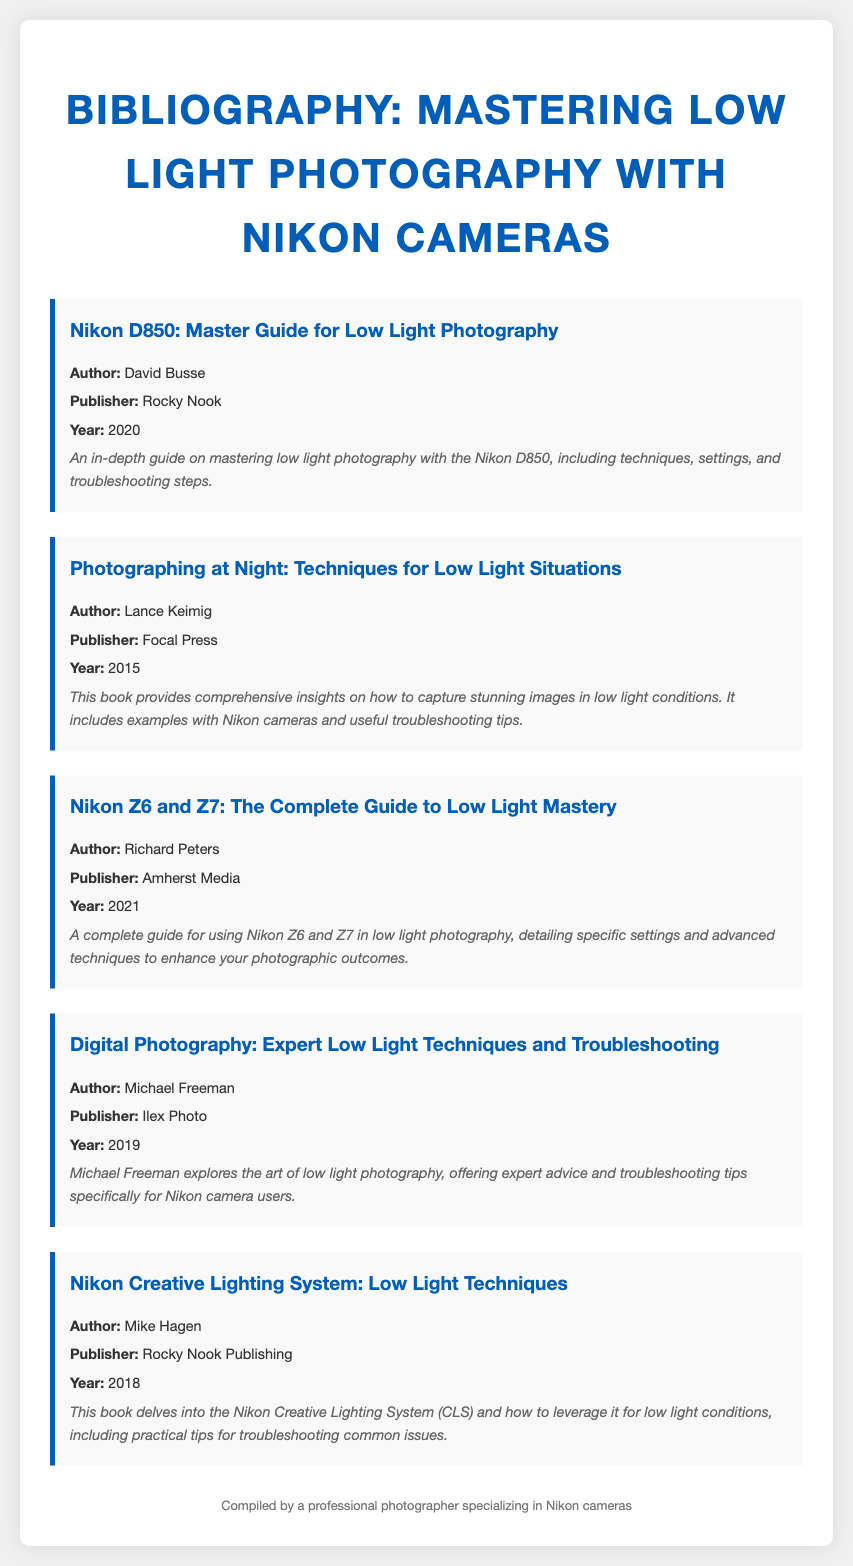what is the title of the first book? The title of the first book in the bibliography is mentioned at the beginning of the first bibliographic entry.
Answer: Nikon D850: Master Guide for Low Light Photography who is the author of the book published by Focal Press? The author of the book published by Focal Press is detailed in the second bibliographic entry.
Answer: Lance Keimig what year was the third book published? The publication year is explicitly stated in the bibliographic details of the third entry.
Answer: 2021 which publisher released the book by Michael Freeman? The publisher for Michael Freeman's book is found in the bibliographic section.
Answer: Ilex Photo what main topic does Mike Hagen's book cover? The main topic of Mike Hagen's book is specified in the description section of his entry.
Answer: Nikon Creative Lighting System how many books are listed in the bibliography? The total number of books is determined by counting the bibliographic items provided in the document.
Answer: 5 what is a common focus among the listed books? The common focus is inferred from the overall theme of the titles and descriptions of the books in the bibliography.
Answer: Low light photography who is the compiled by statement attributed to? The compiled by statement is at the bottom of the document, indicating the person responsible for the bibliography.
Answer: A professional photographer specializing in Nikon cameras 